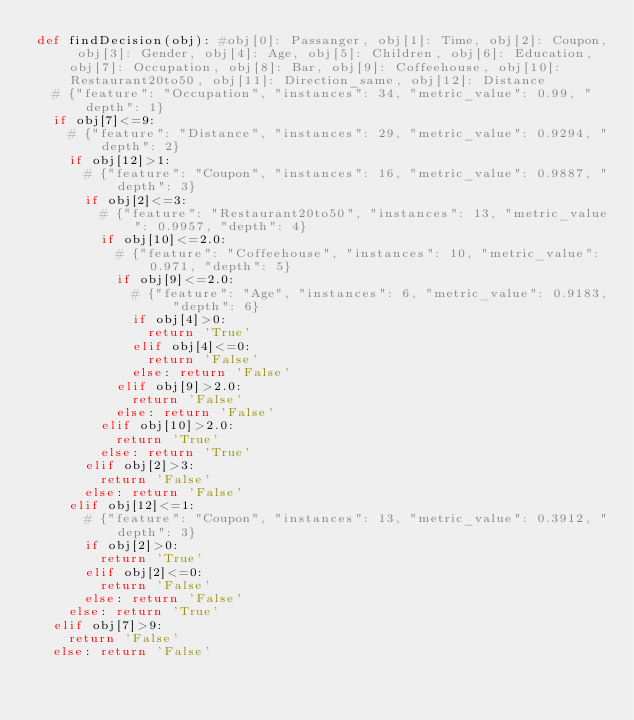<code> <loc_0><loc_0><loc_500><loc_500><_Python_>def findDecision(obj): #obj[0]: Passanger, obj[1]: Time, obj[2]: Coupon, obj[3]: Gender, obj[4]: Age, obj[5]: Children, obj[6]: Education, obj[7]: Occupation, obj[8]: Bar, obj[9]: Coffeehouse, obj[10]: Restaurant20to50, obj[11]: Direction_same, obj[12]: Distance
	# {"feature": "Occupation", "instances": 34, "metric_value": 0.99, "depth": 1}
	if obj[7]<=9:
		# {"feature": "Distance", "instances": 29, "metric_value": 0.9294, "depth": 2}
		if obj[12]>1:
			# {"feature": "Coupon", "instances": 16, "metric_value": 0.9887, "depth": 3}
			if obj[2]<=3:
				# {"feature": "Restaurant20to50", "instances": 13, "metric_value": 0.9957, "depth": 4}
				if obj[10]<=2.0:
					# {"feature": "Coffeehouse", "instances": 10, "metric_value": 0.971, "depth": 5}
					if obj[9]<=2.0:
						# {"feature": "Age", "instances": 6, "metric_value": 0.9183, "depth": 6}
						if obj[4]>0:
							return 'True'
						elif obj[4]<=0:
							return 'False'
						else: return 'False'
					elif obj[9]>2.0:
						return 'False'
					else: return 'False'
				elif obj[10]>2.0:
					return 'True'
				else: return 'True'
			elif obj[2]>3:
				return 'False'
			else: return 'False'
		elif obj[12]<=1:
			# {"feature": "Coupon", "instances": 13, "metric_value": 0.3912, "depth": 3}
			if obj[2]>0:
				return 'True'
			elif obj[2]<=0:
				return 'False'
			else: return 'False'
		else: return 'True'
	elif obj[7]>9:
		return 'False'
	else: return 'False'
</code> 